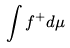<formula> <loc_0><loc_0><loc_500><loc_500>\int f ^ { + } d \mu</formula> 